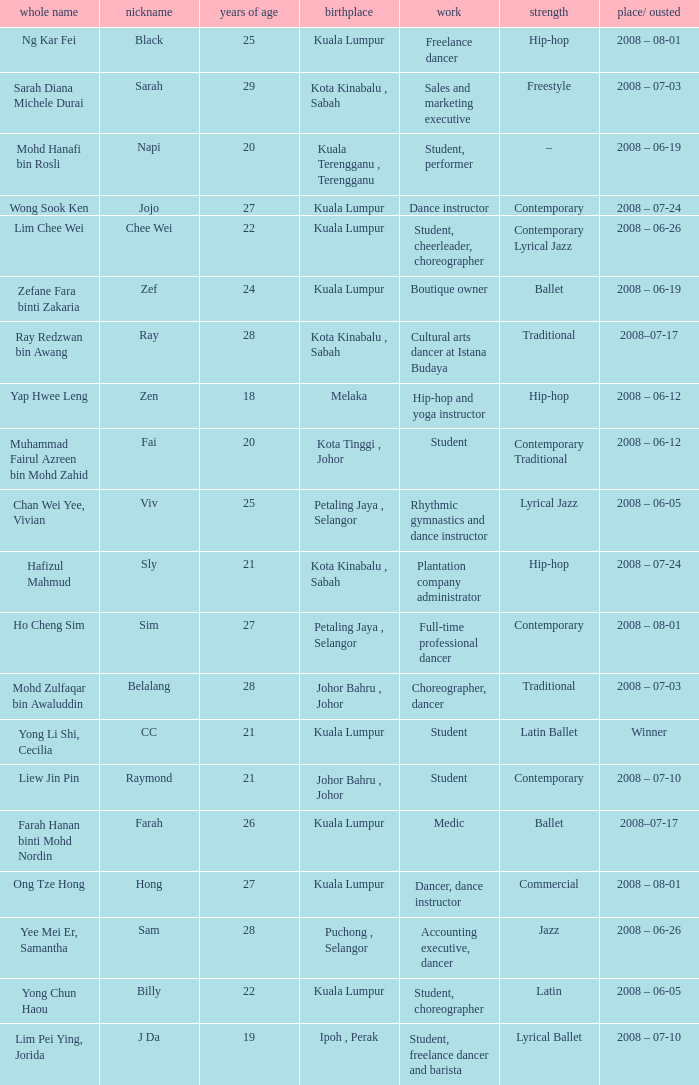What is Position/ Eliminated, when Age¹ is less than 22, and when Full Name is "Muhammad Fairul Azreen Bin Mohd Zahid"? 2008 – 06-12. 